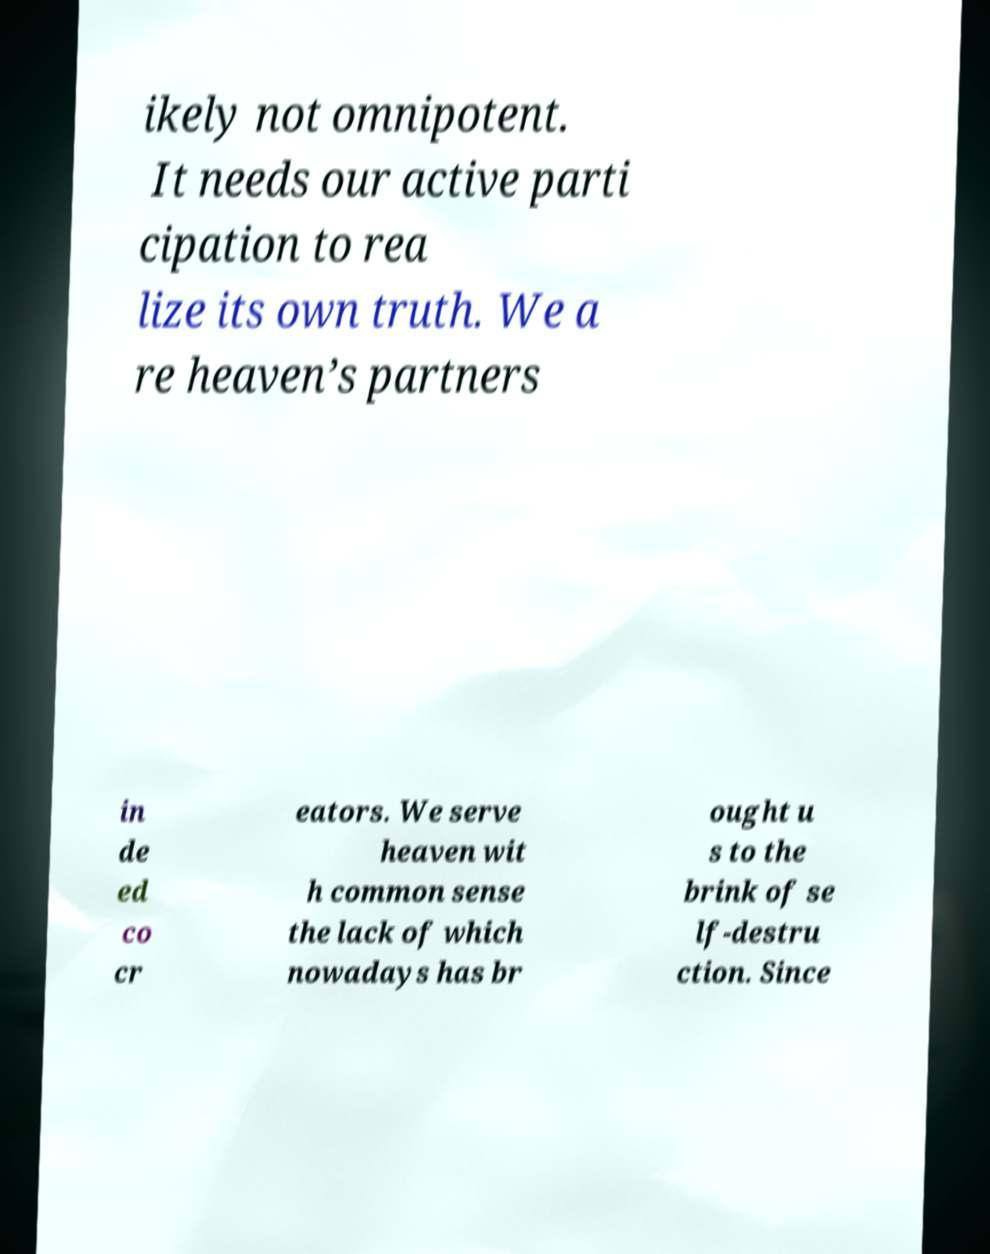There's text embedded in this image that I need extracted. Can you transcribe it verbatim? ikely not omnipotent. It needs our active parti cipation to rea lize its own truth. We a re heaven’s partners in de ed co cr eators. We serve heaven wit h common sense the lack of which nowadays has br ought u s to the brink of se lf-destru ction. Since 